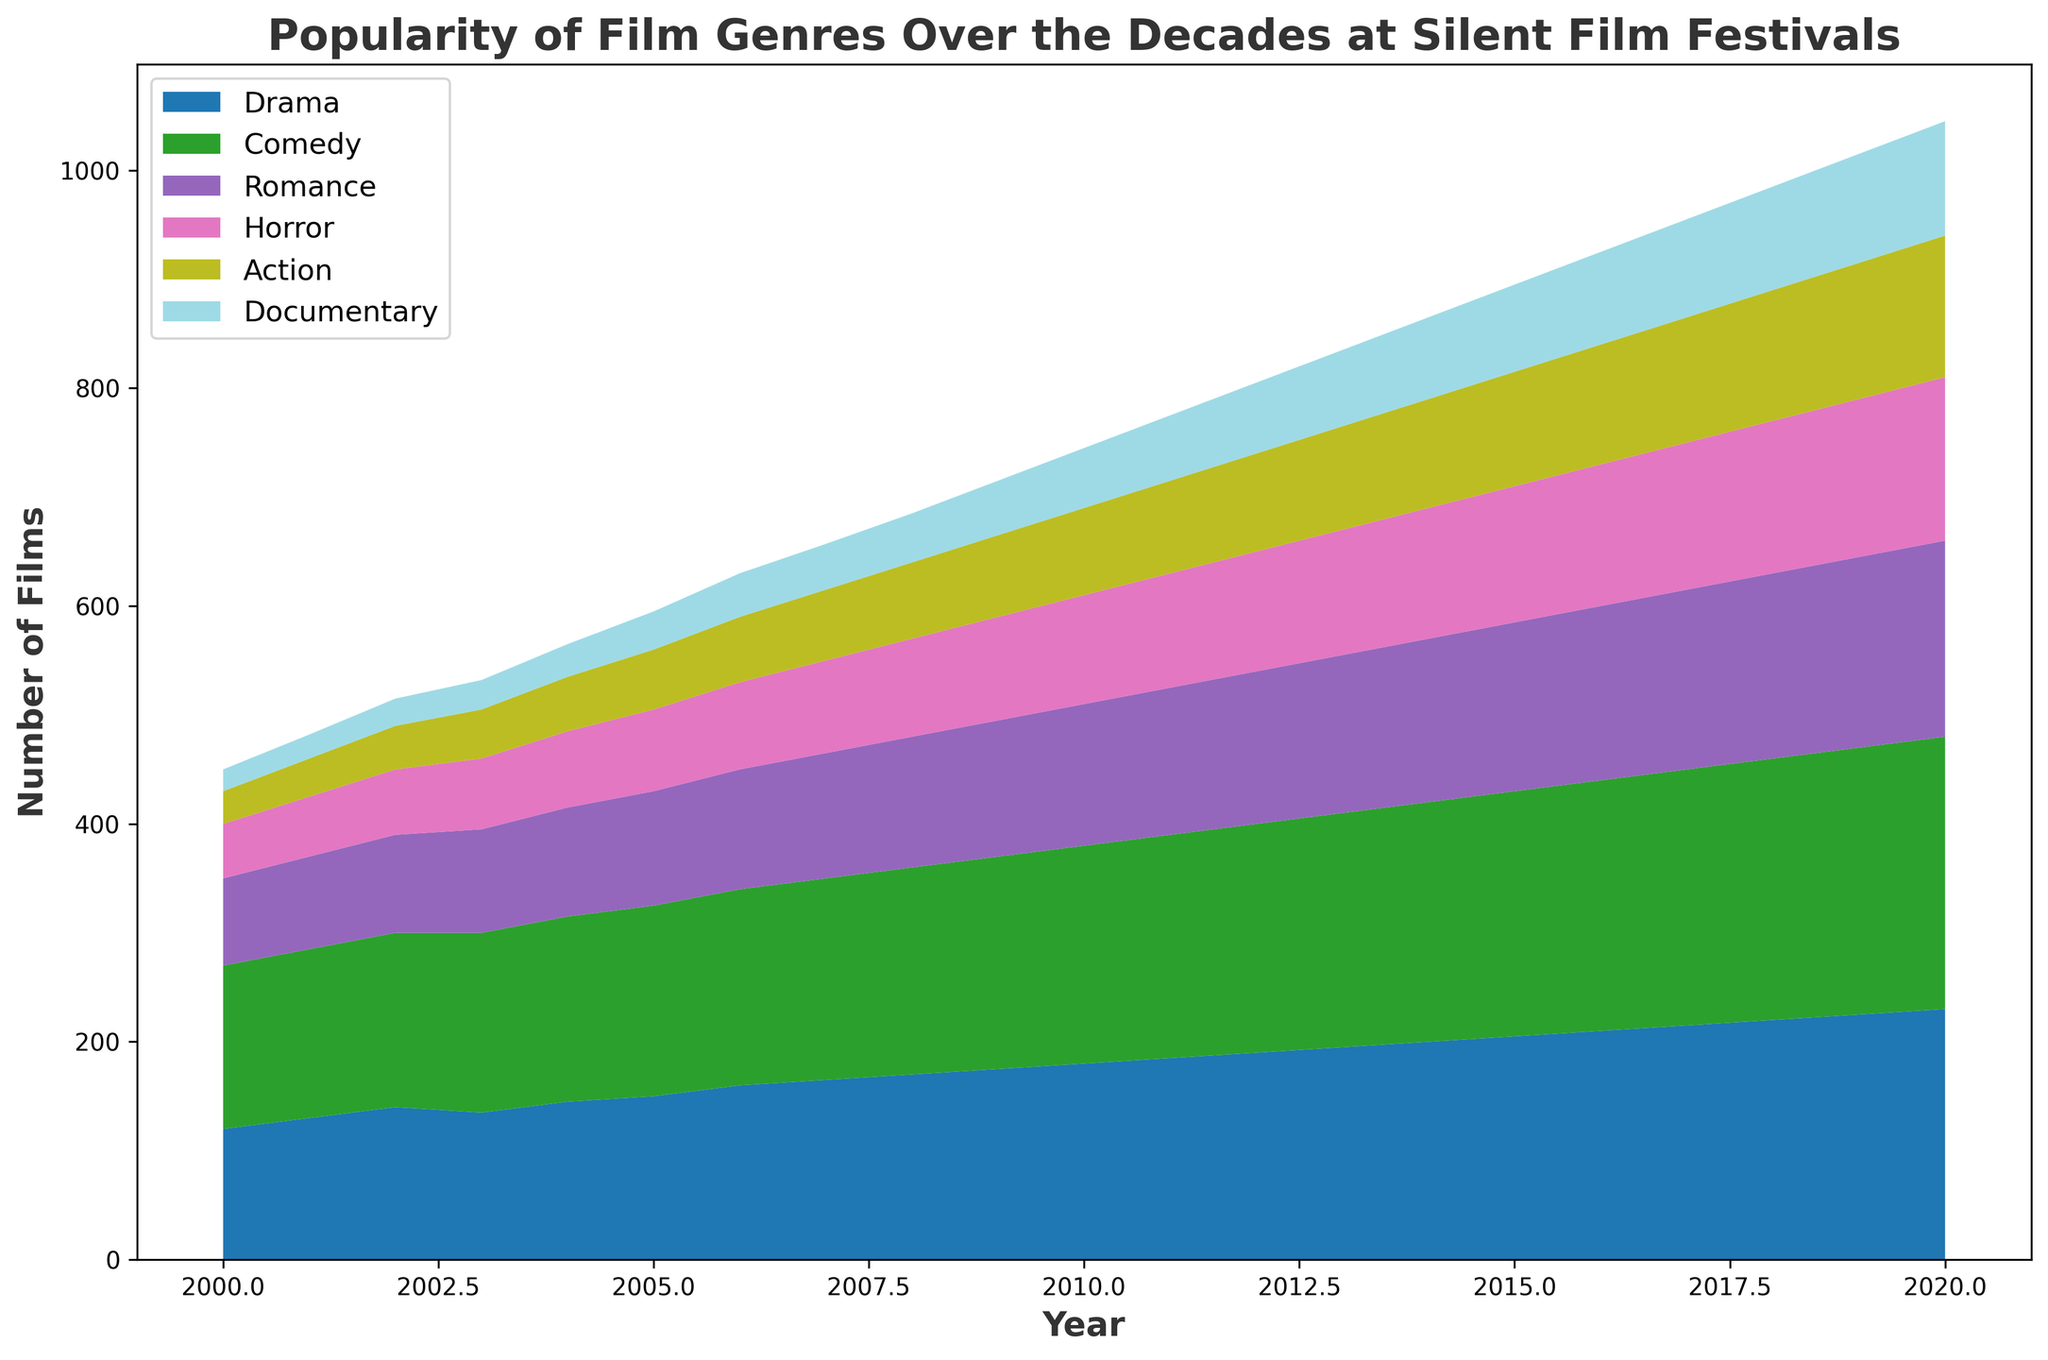How has the popularity of the Drama genre changed over the years? The Drama genre has shown a steady increase in the number of films from 2000 to 2020, starting at 120 films in 2000 and rising to 230 films in 2020.
Answer: Increased Which genre had the highest number of films in 2015? By looking at the area chart, the Comedy genre had the highest number of films in 2015, with 225 films.
Answer: Comedy What is the total number of Horror films in 2005 and 2010? In 2005, there were 75 Horror films, and in 2010, there were 100. Adding these together, 75 + 100 = 175.
Answer: 175 Which genre experienced the biggest increase in film numbers between 2000 and 2020? To determine this, we compare the differences for each genre over the period. Comedy went from 150 to 250 (an increase of 100), Drama from 120 to 230 (an increase of 110), Romance from 80 to 180 (an increase of 100), Horror from 50 to 150 (an increase of 100), Action from 30 to 130 (an increase of 100), and Documentary from 20 to 105 (an increase of 85). Drama had the biggest increase of 110.
Answer: Drama Comparing Documentary and Horror genres in 2010, which had more films and by how much? In 2010, Documentary had 55 films, and Horror had 100 films. The difference is 100 - 55 = 45. Horror had 45 more films than Documentary in 2010.
Answer: Horror by 45 What can be said about the trend for the Documentary genre from 2000 to 2020? The Documentary genre shows a consistent upward trend, starting from 20 films in 2000 and increasing to 105 in 2020.
Answer: Upward trend Which genres had equal numbers of films in any particular year, if any? In 2002, Romance and Horror both had 60 films. No other genres have equal numbers of films in any year according to the data.
Answer: Romance and Horror in 2002 Between 2010 and 2020, did the Action genre grow faster or slower compared to the Romance genre? From 2010 to 2020, Action increased from 80 to 130 (50 films), and Romance from 130 to 180 (50 films). Both genres grew at the same rate, each adding 50 films over this period.
Answer: Same rate What is the average number of Drama films shown per year over the two decades? Summing the Drama films for each year from 2000 to 2020 and dividing by the number of years: (120 + 130 + 140 + 135 + 145 + 150 + 160 + 165 + 170 + 175 + 180 + 185 + 190 + 195 + 200 + 205 + 210 + 215 + 220 + 225 + 230)/21 = 1767/21 ≈ 84.6.
Answer: Approx. 84.6 In which year did the Action genre surpass 100 films for the first time? The Action genre surpassed 100 films for the first time in 2010, where it reached 130 films.
Answer: 2010 